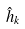Convert formula to latex. <formula><loc_0><loc_0><loc_500><loc_500>\hat { h } _ { k }</formula> 